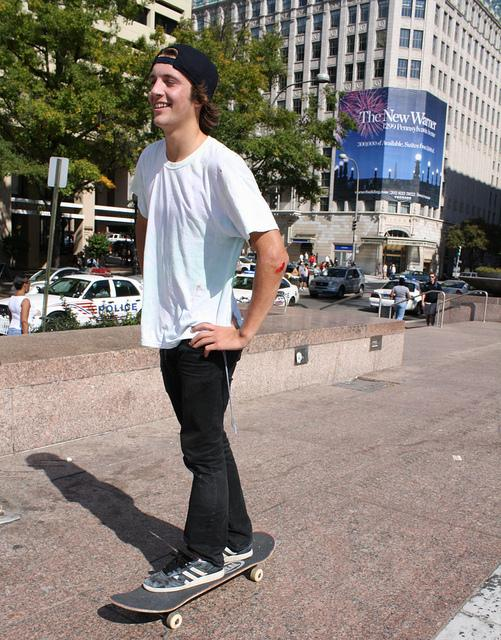What type of shoes is the boy wearing?

Choices:
A) adidas
B) jordan
C) reebok
D) nike adidas 